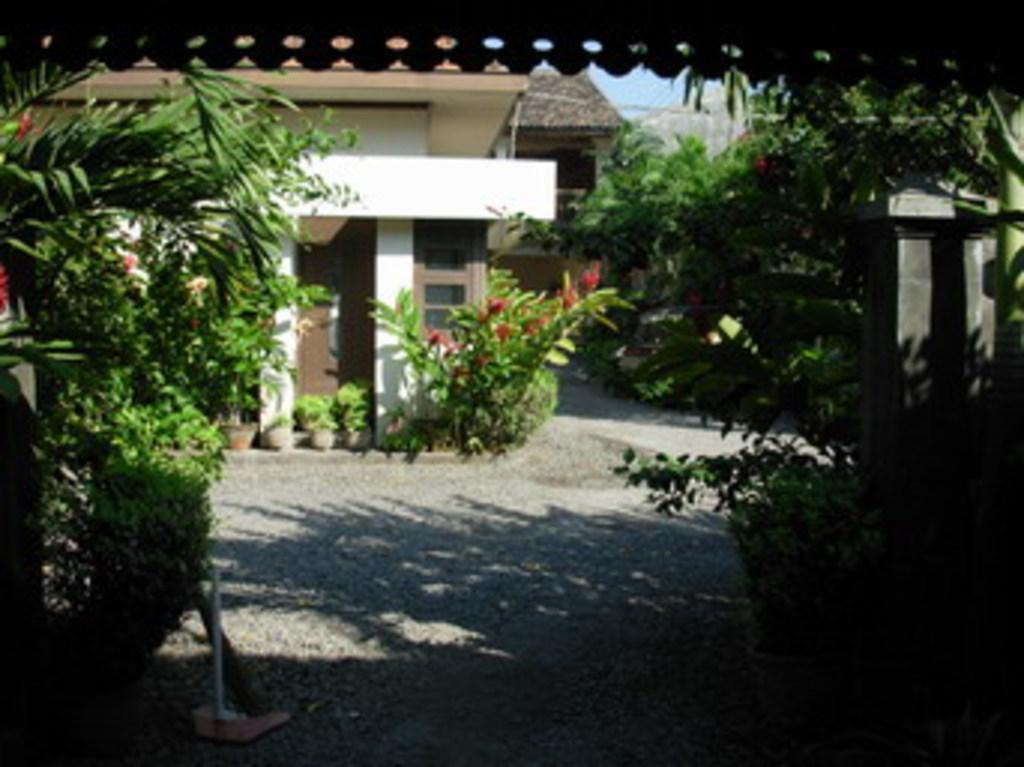Can you describe this image briefly? In this picture we can see some plants on the left side. There are few plants on the right side. We can see some flower pots on the path. There is a building in the background. 